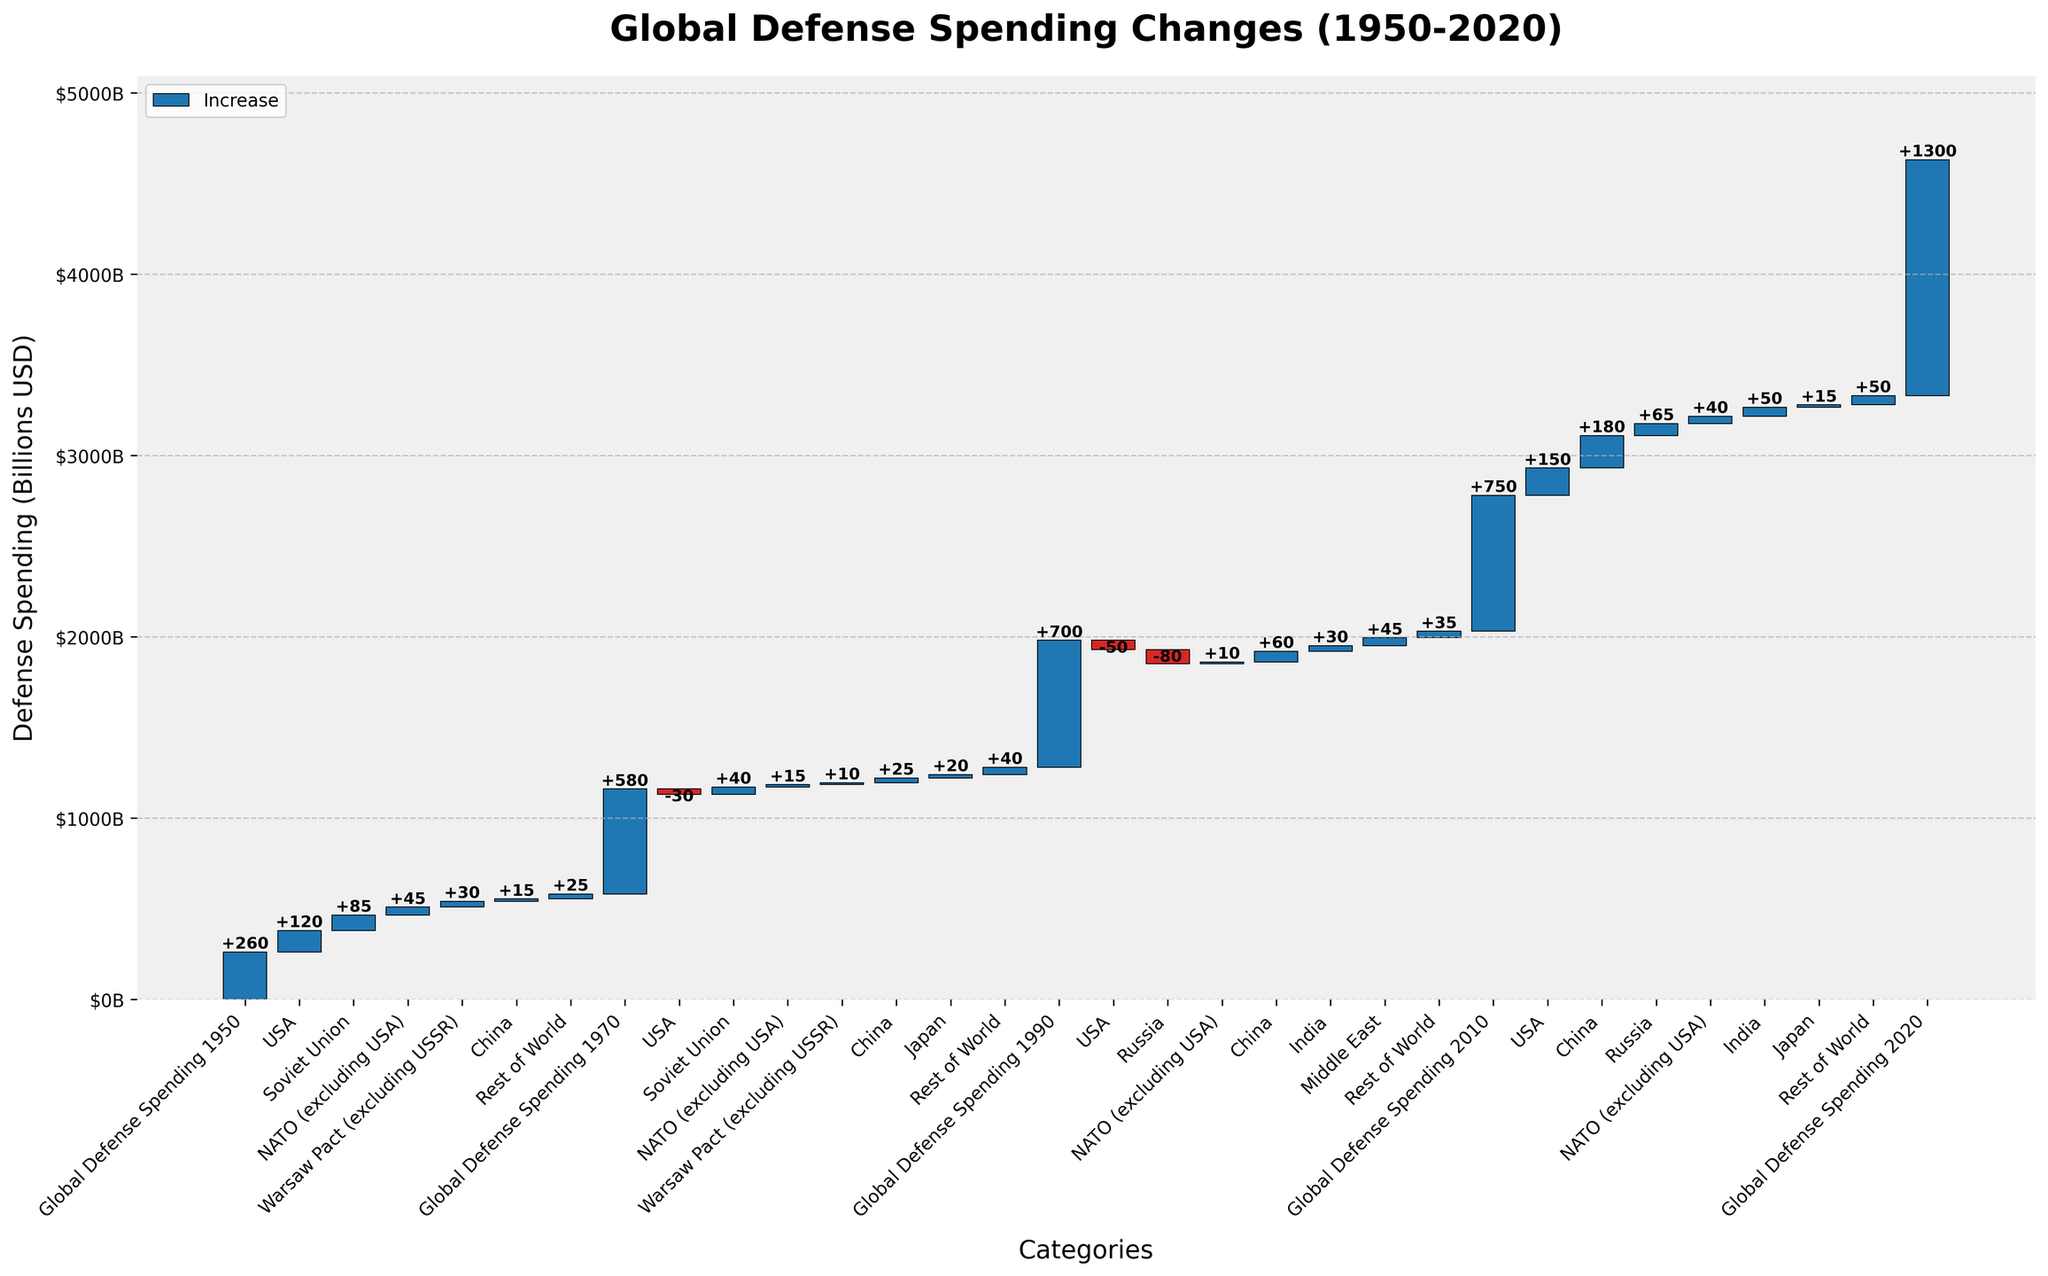How does the global defense spending in 2020 compare to that in 1950? To find the increase in global defense spending from 1950 to 2020, locate the two categories "Global Defense Spending 1950" and "Global Defense Spending 2020". The values are $260B for 1950 and $1300B for 2020. The difference is $1300B - $260B.
Answer: $1040B What is the net change in defense spending for the USA from 1950 to 2020? Identify the incremental changes for the USA in each period: 1950-1970 (+120), 1970-1990 (-30), 1990-2010 (-50), 2010-2020 (+150). Sum these incremental changes: 120 - 30 - 50 + 150.
Answer: +190 Which region showed the greatest increase in defense spending during 2010-2020? To determine the greatest increase, compare the changes in each category from 2010 to 2020. The largest increase is for China with +180.
Answer: China How much did the NATO excluding USA increase its defense spending from 1950 to 1970? Observe the values for NATO excluding USA: from 1950 (+45) to 1970 (+15). Sum these values: +45 + 15.
Answer: +60 Which countries or regions experienced a decline in defense spending between 1990 and 2010? Check all categories between 1990 and 2010. The USA and Russia show declines: USA (-50) and Russia (-80).
Answer: USA and Russia What was the cumulative defense spending of China from 1950 to 2020? Locate the incremental changes for China: 1950-1970 (+15), 1970-1990 (+25), 1990-2010 (+60), 2010-2020 (+180). Sum these incremental values: 15 + 25 + 60 + 180.
Answer: +280 Compare the net changes in defense spending for the Soviet Union between 1950-1970 and Russia between 1990-2010. For the Soviet Union: 1950-1970 (+85 + 40). For Russia: 1990-2010 (-80 + 65). The sums are 85 + 40 = +125 and -80 + 65 = -15.
Answer: +125 and -15 What is the overall change in global defense spending between 1950 and 1990? Calculate the difference between global defense spending in 1990 ($700B) and 1950 ($260B): 700 - 260.
Answer: $440B How much did Japan increase its defense spending after 1970? Identify the incremental changes for Japan: 1970-1990 (+20) and 2010-2020 (+15). Sum these changes: 20 + 15.
Answer: +35 Which category had the smallest change in spending from 2010 to 2020? Observe all changes listed for 2010-2020. The smallest change is for Japan with +15.
Answer: Japan 